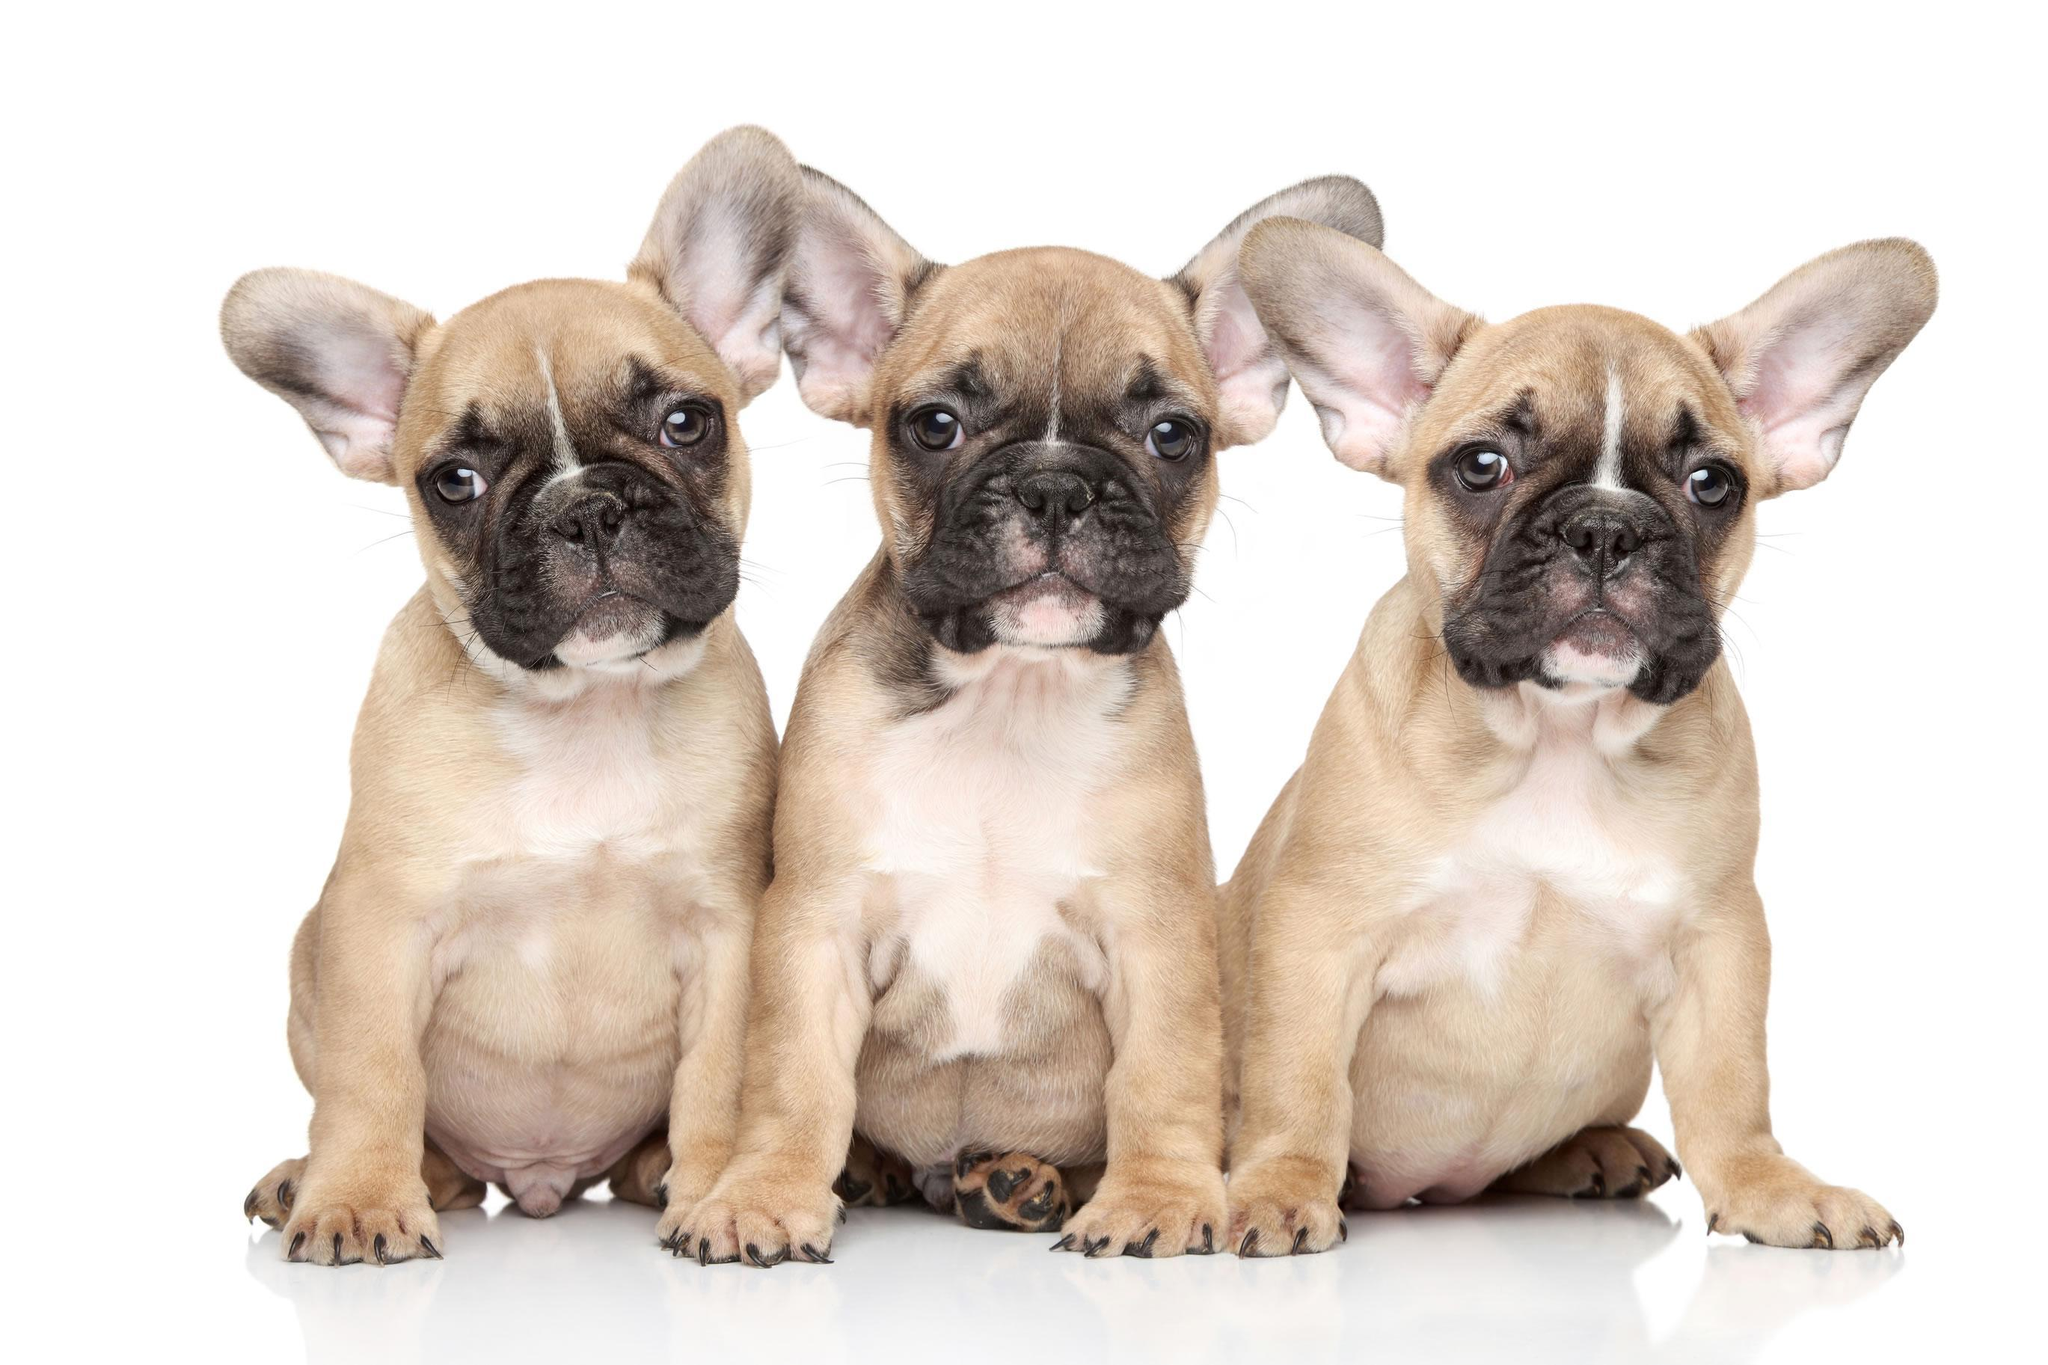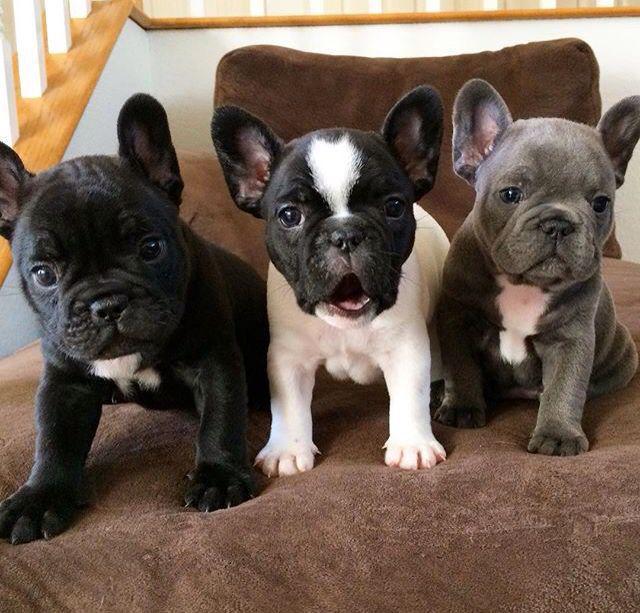The first image is the image on the left, the second image is the image on the right. Given the left and right images, does the statement "The right image contains exactly three dogs." hold true? Answer yes or no. Yes. The first image is the image on the left, the second image is the image on the right. Assess this claim about the two images: "There are no more than five puppies in the pair of images.". Correct or not? Answer yes or no. No. 